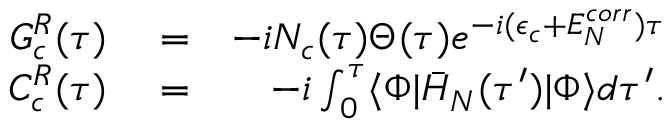Convert formula to latex. <formula><loc_0><loc_0><loc_500><loc_500>\begin{array} { r l r } { G _ { c } ^ { R } ( \tau ) } & = } & { - i N _ { c } ( \tau ) \Theta ( \tau ) e ^ { - i ( \epsilon _ { c } + E _ { N } ^ { c o r r } ) \tau } } \\ { C _ { c } ^ { R } ( \tau ) } & = } & { - i \int _ { 0 } ^ { \tau } \langle \Phi | \bar { H } _ { N } ( \tau ^ { \prime } ) | \Phi \rangle d \tau ^ { \prime } . } \end{array}</formula> 